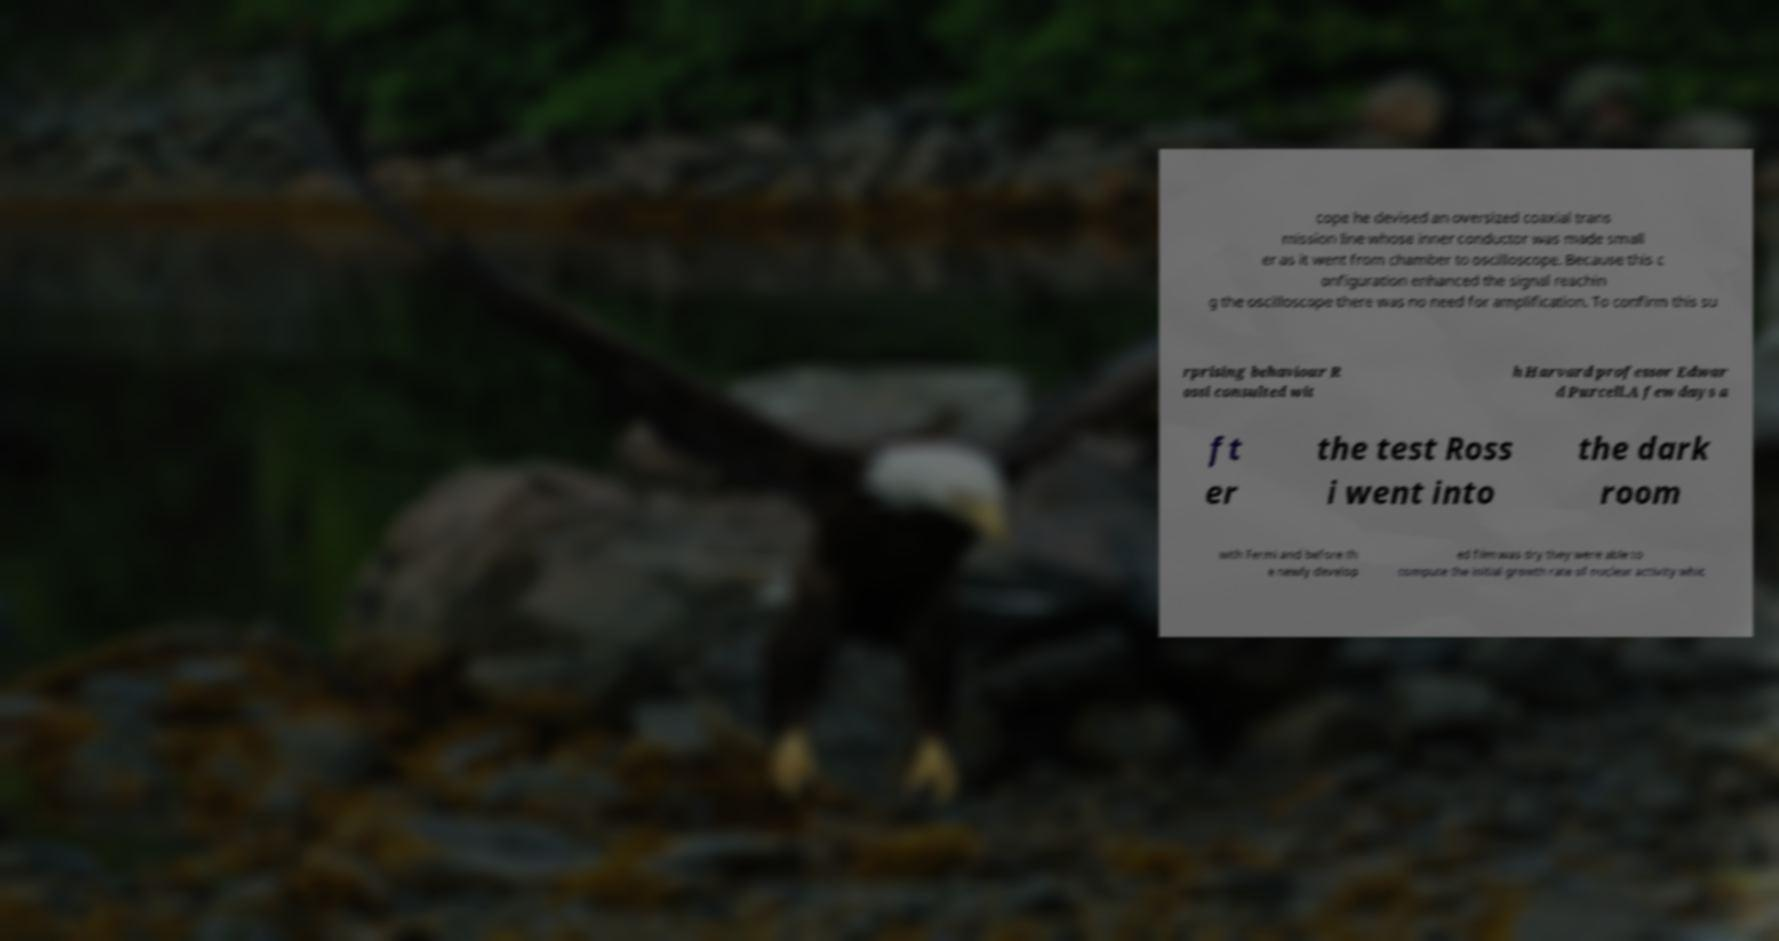I need the written content from this picture converted into text. Can you do that? cope he devised an oversized coaxial trans mission line whose inner conductor was made small er as it went from chamber to oscilloscope. Because this c onfiguration enhanced the signal reachin g the oscilloscope there was no need for amplification. To confirm this su rprising behaviour R ossi consulted wit h Harvard professor Edwar d Purcell.A few days a ft er the test Ross i went into the dark room with Fermi and before th e newly develop ed film was dry they were able to compute the initial growth rate of nuclear activity whic 